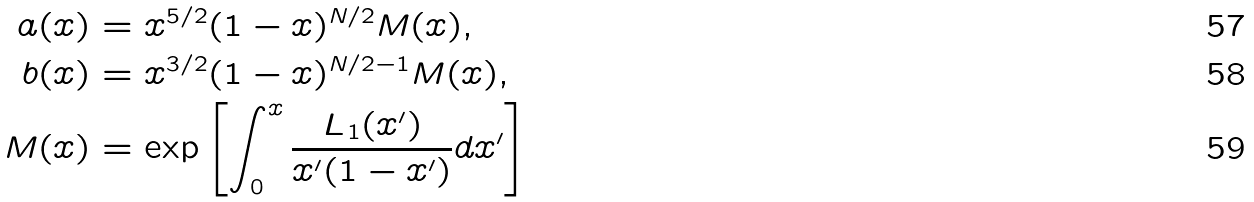Convert formula to latex. <formula><loc_0><loc_0><loc_500><loc_500>a ( x ) & = x ^ { 5 / 2 } ( 1 - x ) ^ { N / 2 } M ( x ) , \\ b ( x ) & = x ^ { 3 / 2 } ( 1 - x ) ^ { N / 2 - 1 } M ( x ) , \\ M ( x ) & = \exp \left [ \int _ { 0 } ^ { x } \frac { L _ { 1 } ( x ^ { \prime } ) } { x ^ { \prime } ( 1 - x ^ { \prime } ) } d x ^ { \prime } \right ]</formula> 